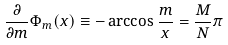<formula> <loc_0><loc_0><loc_500><loc_500>\frac { \partial } { \partial m } \Phi _ { m } ( x ) \equiv - \arccos \frac { m } { x } = \frac { M } { N } \pi</formula> 